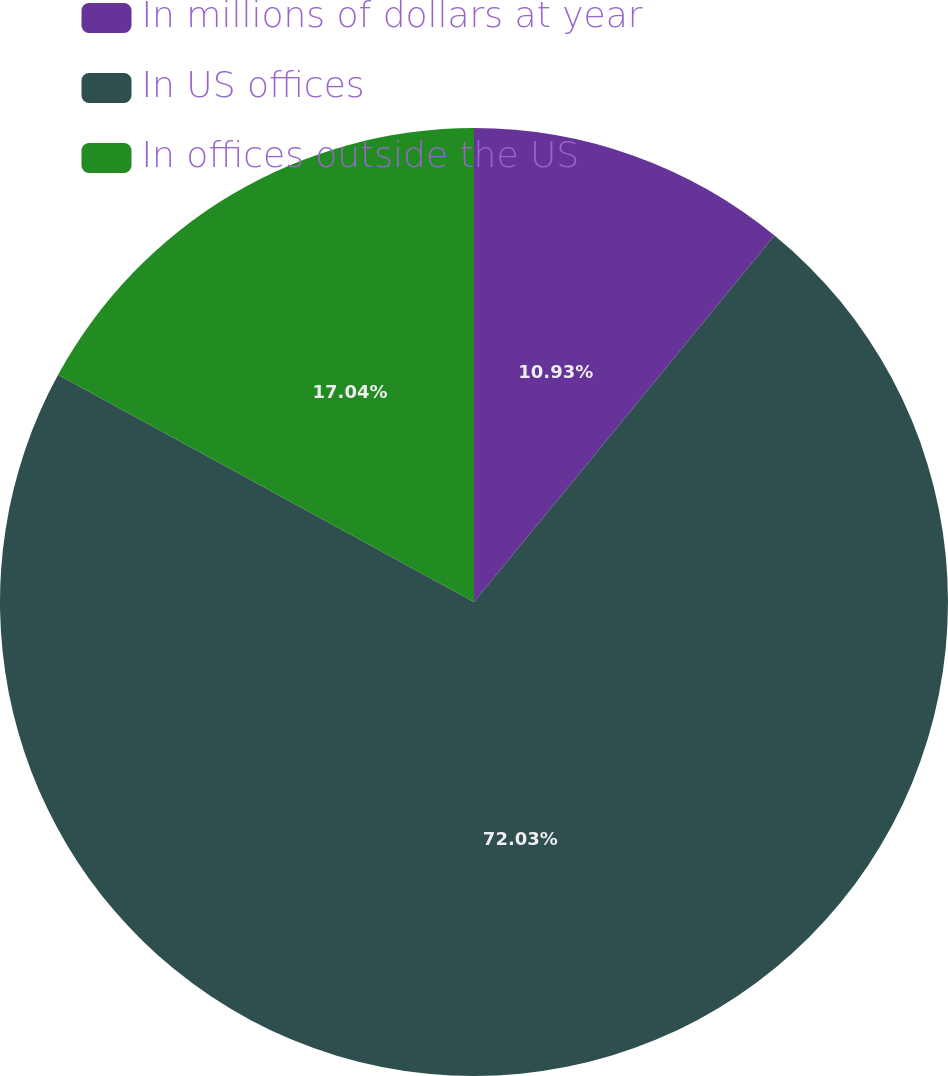Convert chart to OTSL. <chart><loc_0><loc_0><loc_500><loc_500><pie_chart><fcel>In millions of dollars at year<fcel>In US offices<fcel>In offices outside the US<nl><fcel>10.93%<fcel>72.04%<fcel>17.04%<nl></chart> 